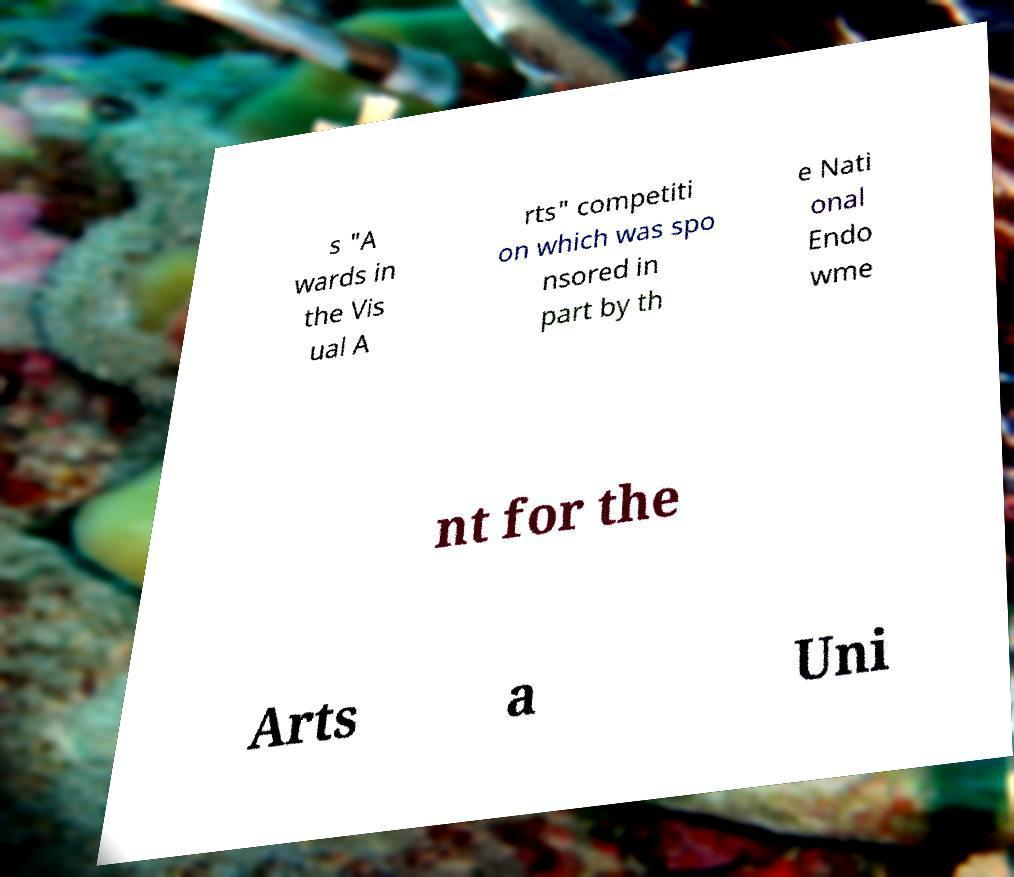Can you read and provide the text displayed in the image?This photo seems to have some interesting text. Can you extract and type it out for me? s "A wards in the Vis ual A rts" competiti on which was spo nsored in part by th e Nati onal Endo wme nt for the Arts a Uni 